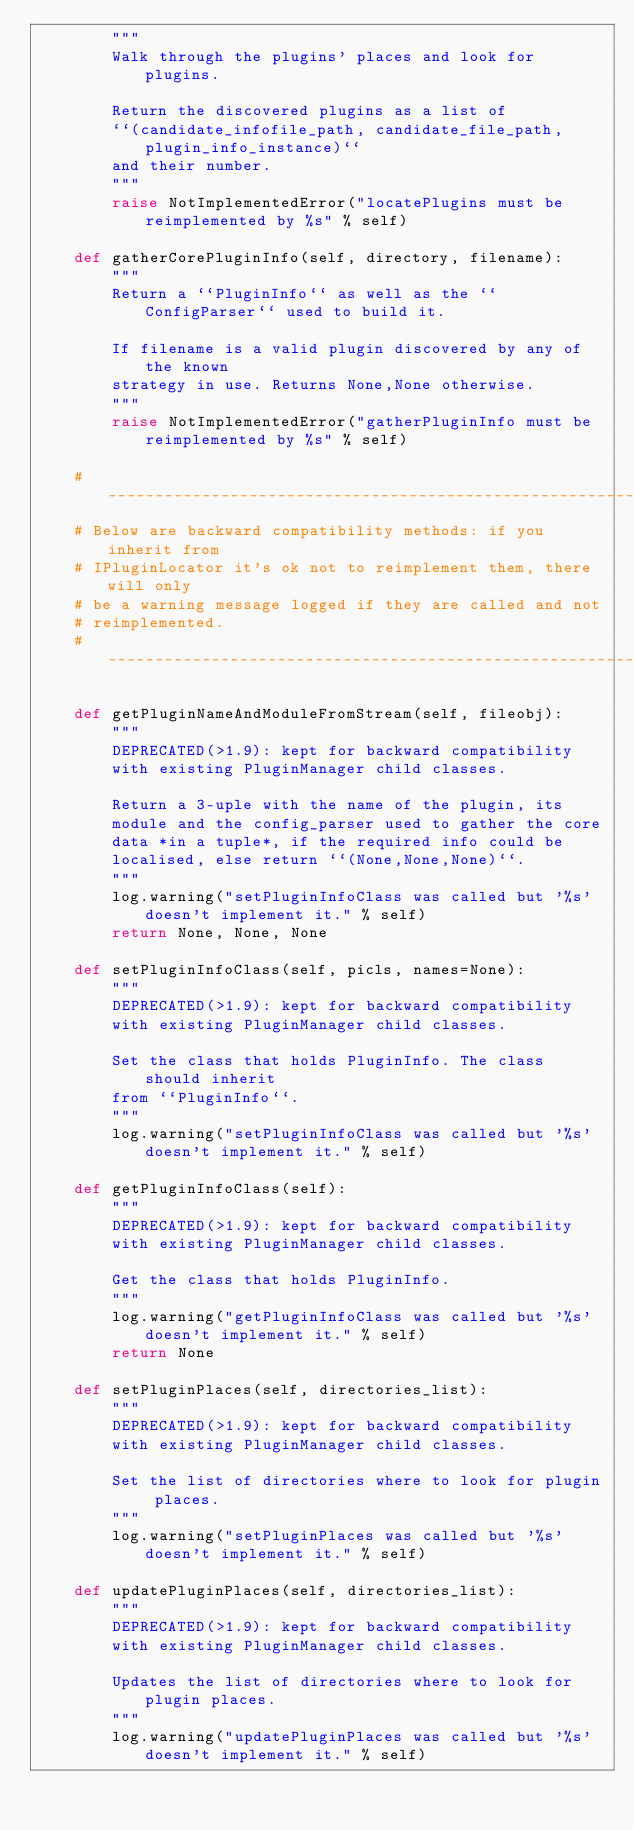Convert code to text. <code><loc_0><loc_0><loc_500><loc_500><_Python_>        """
        Walk through the plugins' places and look for plugins.

        Return the discovered plugins as a list of
        ``(candidate_infofile_path, candidate_file_path,plugin_info_instance)``
        and their number.
        """
        raise NotImplementedError("locatePlugins must be reimplemented by %s" % self)

    def gatherCorePluginInfo(self, directory, filename):
        """
        Return a ``PluginInfo`` as well as the ``ConfigParser`` used to build it.
        
        If filename is a valid plugin discovered by any of the known
        strategy in use. Returns None,None otherwise.
        """
        raise NotImplementedError("gatherPluginInfo must be reimplemented by %s" % self)

    # --------------------------------------------------------------------
    # Below are backward compatibility methods: if you inherit from
    # IPluginLocator it's ok not to reimplement them, there will only
    # be a warning message logged if they are called and not
    # reimplemented.
    # --------------------------------------------------------------------

    def getPluginNameAndModuleFromStream(self, fileobj):
        """
        DEPRECATED(>1.9): kept for backward compatibility
        with existing PluginManager child classes.
        
        Return a 3-uple with the name of the plugin, its
        module and the config_parser used to gather the core
        data *in a tuple*, if the required info could be
        localised, else return ``(None,None,None)``.
        """
        log.warning("setPluginInfoClass was called but '%s' doesn't implement it." % self)
        return None, None, None

    def setPluginInfoClass(self, picls, names=None):
        """
        DEPRECATED(>1.9): kept for backward compatibility
        with existing PluginManager child classes.
        
        Set the class that holds PluginInfo. The class should inherit
        from ``PluginInfo``.
        """
        log.warning("setPluginInfoClass was called but '%s' doesn't implement it." % self)

    def getPluginInfoClass(self):
        """
        DEPRECATED(>1.9): kept for backward compatibility
        with existing PluginManager child classes.
        
        Get the class that holds PluginInfo.
        """
        log.warning("getPluginInfoClass was called but '%s' doesn't implement it." % self)
        return None

    def setPluginPlaces(self, directories_list):
        """
        DEPRECATED(>1.9): kept for backward compatibility
        with existing PluginManager child classes.
        
        Set the list of directories where to look for plugin places.
        """
        log.warning("setPluginPlaces was called but '%s' doesn't implement it." % self)

    def updatePluginPlaces(self, directories_list):
        """
        DEPRECATED(>1.9): kept for backward compatibility
        with existing PluginManager child classes.
        
        Updates the list of directories where to look for plugin places.
        """
        log.warning("updatePluginPlaces was called but '%s' doesn't implement it." % self)
</code> 